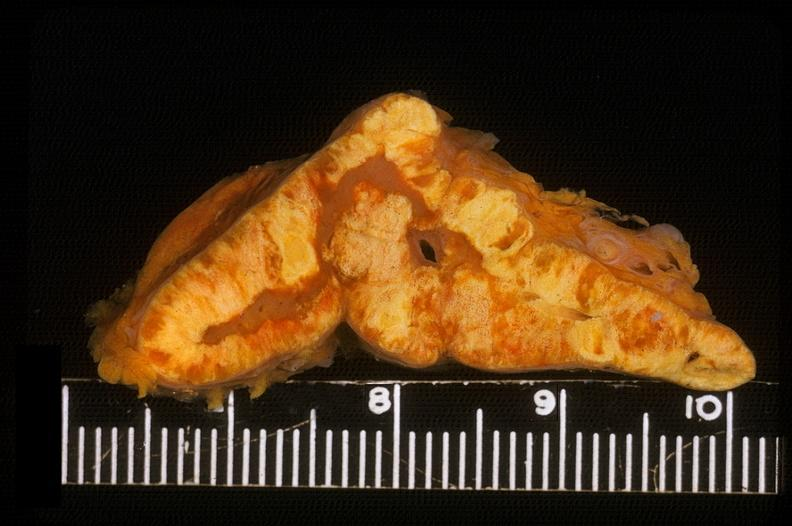does tuberculosis show adrenal, cortical hyperplasia?
Answer the question using a single word or phrase. No 